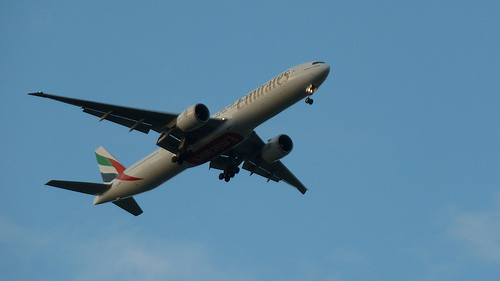Are there any airplanes? Yes, there is an airplane captured in the image, shown flying in the sky. 